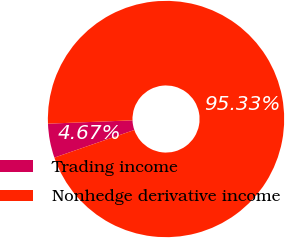Convert chart. <chart><loc_0><loc_0><loc_500><loc_500><pie_chart><fcel>Trading income<fcel>Nonhedge derivative income<nl><fcel>4.67%<fcel>95.33%<nl></chart> 